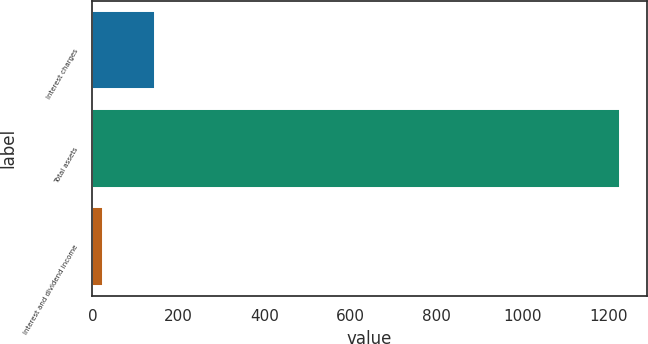Convert chart. <chart><loc_0><loc_0><loc_500><loc_500><bar_chart><fcel>Interest charges<fcel>Total assets<fcel>Interest and dividend income<nl><fcel>145.3<fcel>1228<fcel>25<nl></chart> 